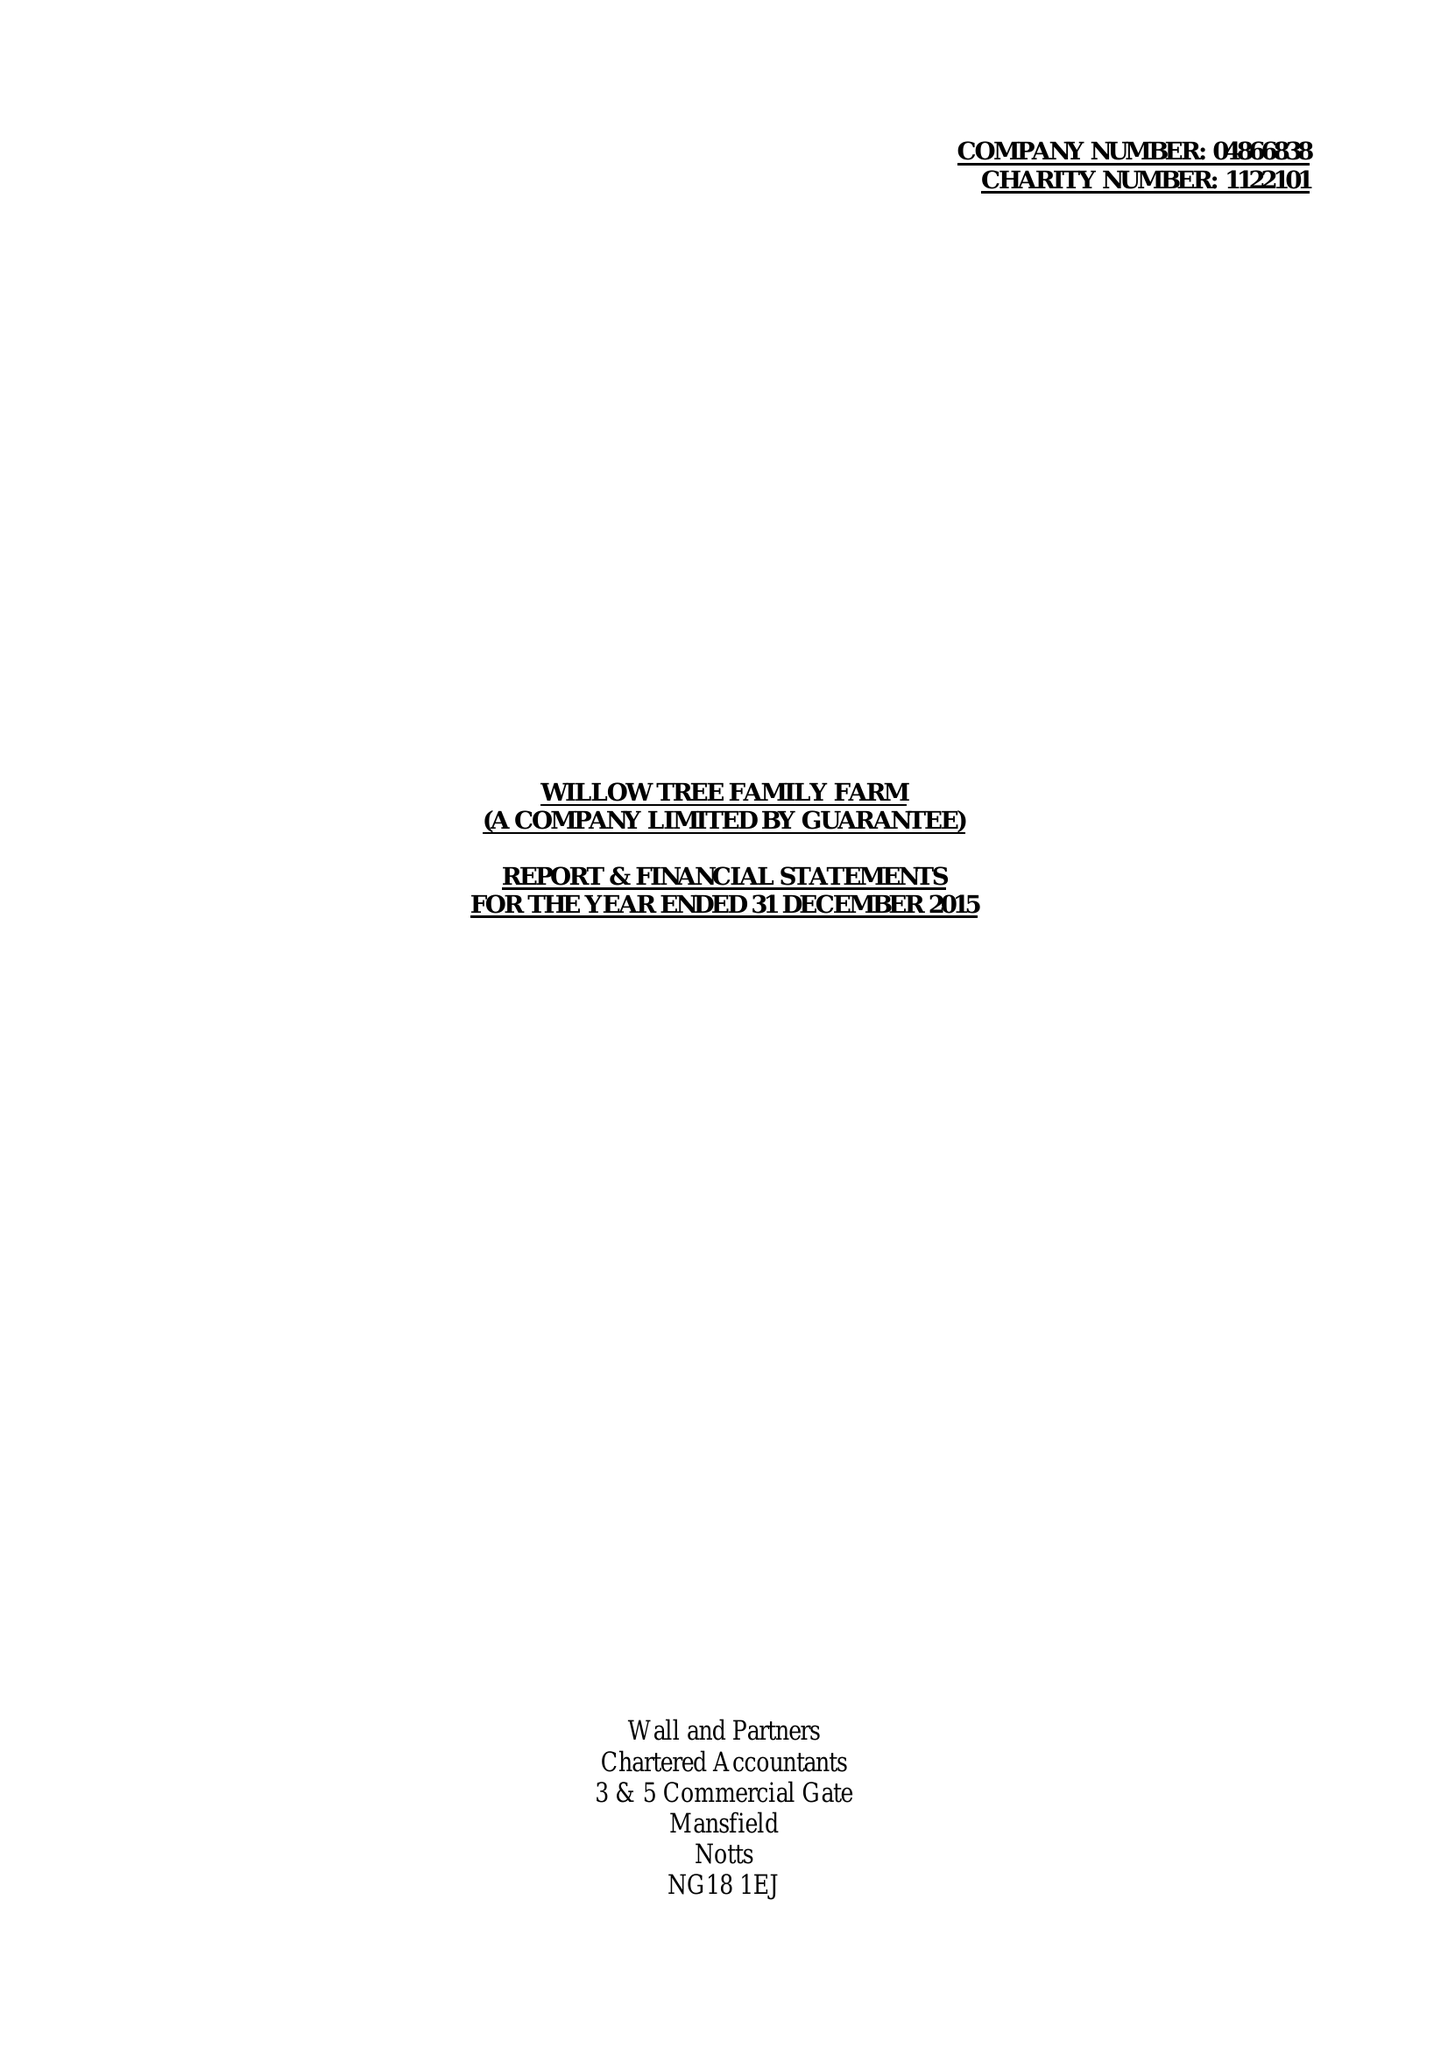What is the value for the charity_name?
Answer the question using a single word or phrase. Willow Tree Family Farm 